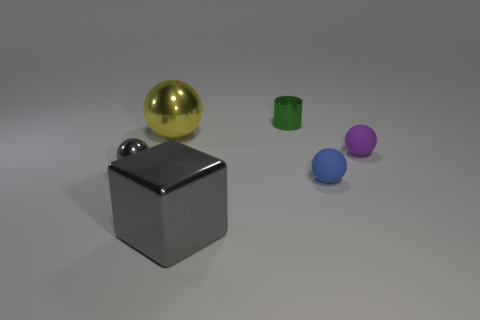There is a thing that is the same color as the metallic block; what is it made of?
Make the answer very short. Metal. Are there any other things that have the same shape as the small blue rubber object?
Provide a succinct answer. Yes. Is the large gray block made of the same material as the big thing that is behind the big cube?
Give a very brief answer. Yes. What color is the large object that is to the left of the gray shiny thing to the right of the tiny thing that is left of the big gray block?
Offer a very short reply. Yellow. Is there any other thing that has the same size as the block?
Your response must be concise. Yes. There is a small metallic ball; does it have the same color as the sphere on the right side of the blue thing?
Your answer should be very brief. No. The cylinder has what color?
Give a very brief answer. Green. The thing behind the metallic sphere that is right of the small metal object in front of the purple matte object is what shape?
Provide a short and direct response. Cylinder. How many other things are the same color as the cube?
Your answer should be very brief. 1. Are there more tiny shiny objects that are in front of the purple matte ball than cubes that are to the left of the blue rubber sphere?
Ensure brevity in your answer.  No. 